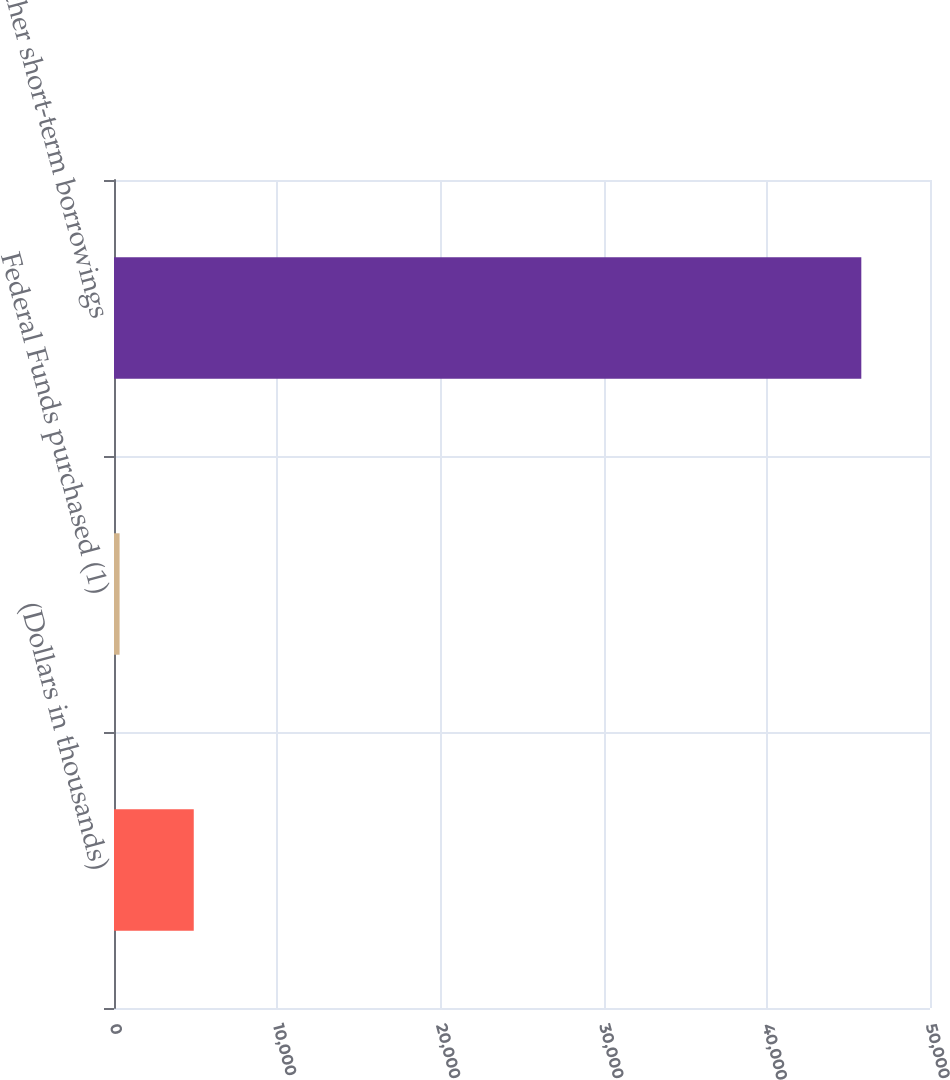Convert chart. <chart><loc_0><loc_0><loc_500><loc_500><bar_chart><fcel>(Dollars in thousands)<fcel>Federal Funds purchased (1)<fcel>Other short-term borrowings<nl><fcel>4886.9<fcel>342<fcel>45791<nl></chart> 